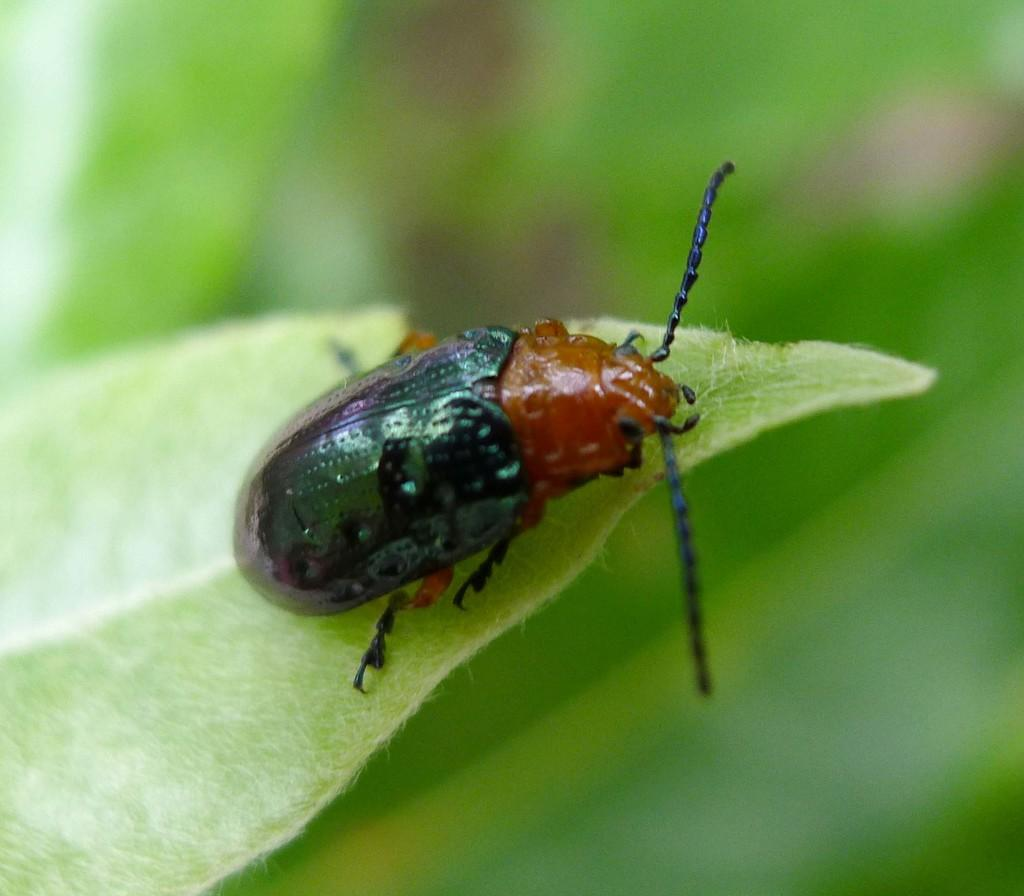What is the main subject of the image? There is an insect on a leaf in the image. Can you describe the background of the image? The background of the image is blurred. What type of thrill can be seen in the image? There is no thrill present in the image; it features an insect on a leaf with a blurred background. What material is the lead made of in the image? There is no lead present in the image. 